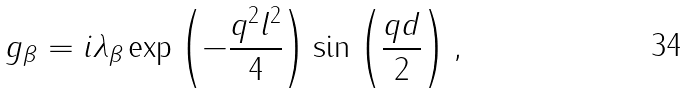Convert formula to latex. <formula><loc_0><loc_0><loc_500><loc_500>g _ { \beta } = i \lambda _ { \beta } \exp \left ( - \frac { q ^ { 2 } l ^ { 2 } } { 4 } \right ) \sin \left ( \frac { q d } { 2 } \right ) ,</formula> 